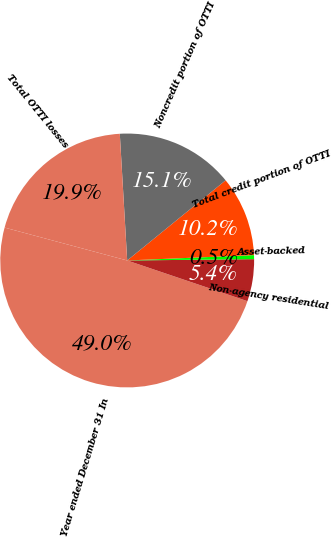<chart> <loc_0><loc_0><loc_500><loc_500><pie_chart><fcel>Year ended December 31 In<fcel>Non-agency residential<fcel>Asset-backed<fcel>Total credit portion of OTTI<fcel>Noncredit portion of OTTI<fcel>Total OTTI losses<nl><fcel>48.98%<fcel>5.36%<fcel>0.51%<fcel>10.2%<fcel>15.05%<fcel>19.9%<nl></chart> 